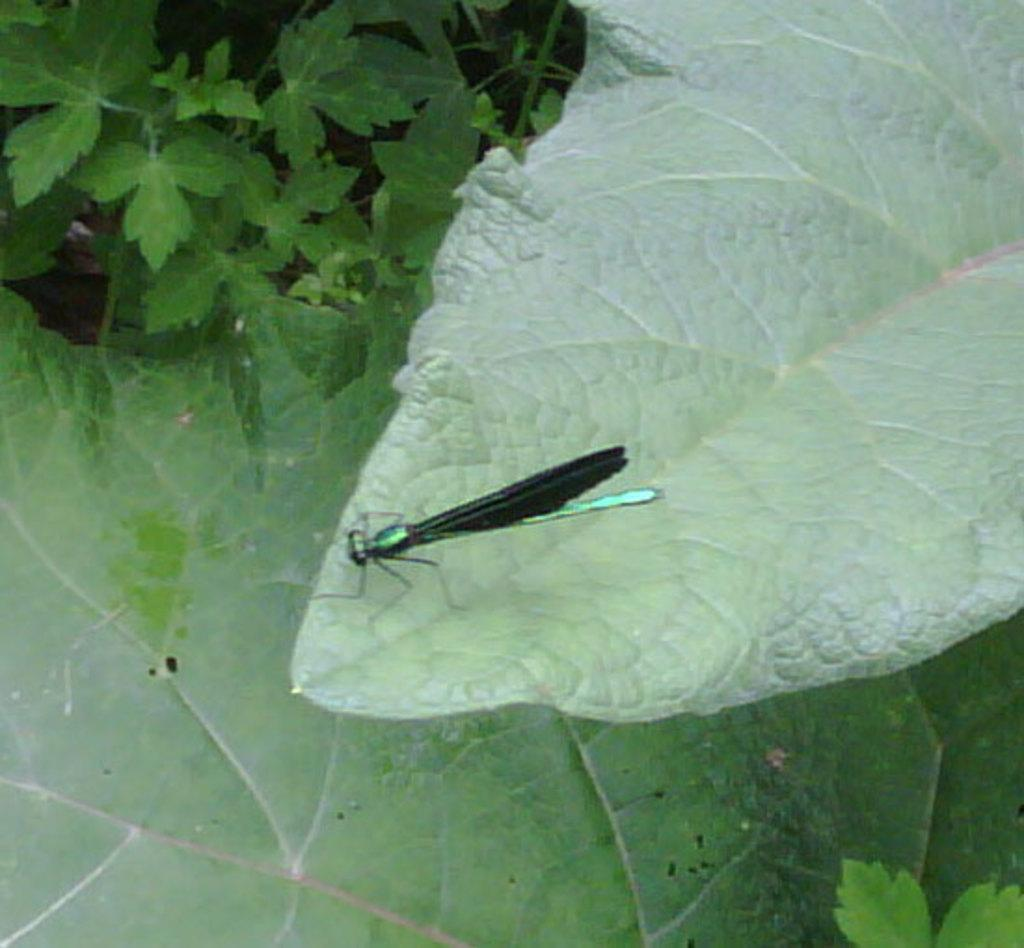What type of creature is in the image? There is an insect in the image. Where is the insect located? The insect is sitting on a leaf. What else can be seen in the image besides the insect? There are leaves visible in the image. What type of furniture can be seen in the image? There is no furniture present in the image; it features an insect sitting on a leaf. Is there a rabbit visible in the image? There is no rabbit present in the image; it only features an insect and leaves. 